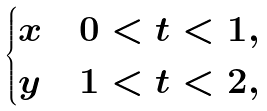Convert formula to latex. <formula><loc_0><loc_0><loc_500><loc_500>\begin{cases} x & 0 < t < 1 , \\ y & 1 < t < 2 , \end{cases}</formula> 